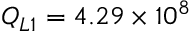Convert formula to latex. <formula><loc_0><loc_0><loc_500><loc_500>Q _ { L 1 } = 4 . 2 9 \times 1 0 ^ { 8 }</formula> 